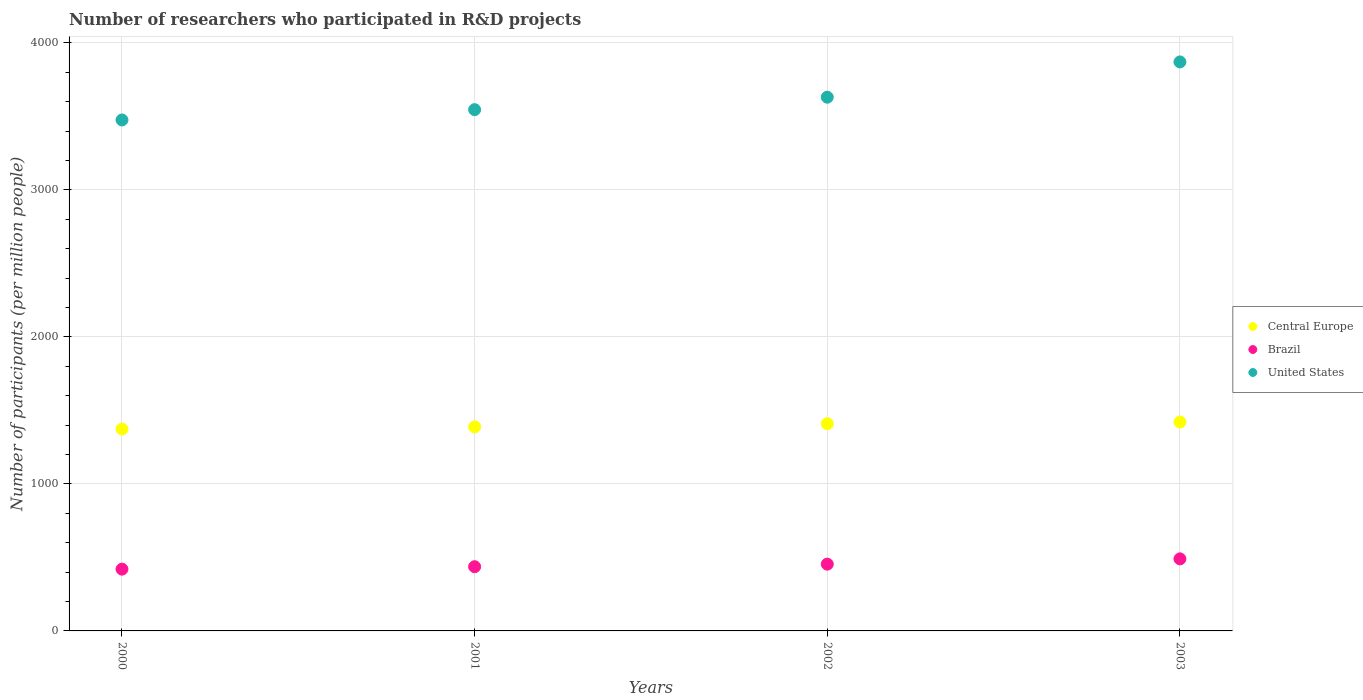What is the number of researchers who participated in R&D projects in Brazil in 2002?
Provide a succinct answer. 454.21. Across all years, what is the maximum number of researchers who participated in R&D projects in Central Europe?
Provide a short and direct response. 1420.86. Across all years, what is the minimum number of researchers who participated in R&D projects in Central Europe?
Offer a terse response. 1373.22. In which year was the number of researchers who participated in R&D projects in United States maximum?
Keep it short and to the point. 2003. In which year was the number of researchers who participated in R&D projects in Brazil minimum?
Your answer should be very brief. 2000. What is the total number of researchers who participated in R&D projects in Brazil in the graph?
Your response must be concise. 1801.45. What is the difference between the number of researchers who participated in R&D projects in United States in 2001 and that in 2002?
Offer a very short reply. -84.77. What is the difference between the number of researchers who participated in R&D projects in United States in 2002 and the number of researchers who participated in R&D projects in Brazil in 2000?
Your answer should be very brief. 3210.07. What is the average number of researchers who participated in R&D projects in Central Europe per year?
Offer a very short reply. 1397.9. In the year 2001, what is the difference between the number of researchers who participated in R&D projects in Brazil and number of researchers who participated in R&D projects in United States?
Make the answer very short. -3108.79. What is the ratio of the number of researchers who participated in R&D projects in United States in 2001 to that in 2003?
Offer a terse response. 0.92. Is the difference between the number of researchers who participated in R&D projects in Brazil in 2000 and 2001 greater than the difference between the number of researchers who participated in R&D projects in United States in 2000 and 2001?
Provide a short and direct response. Yes. What is the difference between the highest and the second highest number of researchers who participated in R&D projects in Brazil?
Your response must be concise. 36.01. What is the difference between the highest and the lowest number of researchers who participated in R&D projects in United States?
Provide a succinct answer. 394.69. In how many years, is the number of researchers who participated in R&D projects in Central Europe greater than the average number of researchers who participated in R&D projects in Central Europe taken over all years?
Provide a succinct answer. 2. Does the number of researchers who participated in R&D projects in United States monotonically increase over the years?
Offer a terse response. Yes. Is the number of researchers who participated in R&D projects in Central Europe strictly greater than the number of researchers who participated in R&D projects in United States over the years?
Ensure brevity in your answer.  No. Are the values on the major ticks of Y-axis written in scientific E-notation?
Offer a terse response. No. Where does the legend appear in the graph?
Give a very brief answer. Center right. How many legend labels are there?
Provide a succinct answer. 3. What is the title of the graph?
Keep it short and to the point. Number of researchers who participated in R&D projects. What is the label or title of the X-axis?
Keep it short and to the point. Years. What is the label or title of the Y-axis?
Your answer should be very brief. Number of participants (per million people). What is the Number of participants (per million people) of Central Europe in 2000?
Make the answer very short. 1373.22. What is the Number of participants (per million people) in Brazil in 2000?
Your answer should be compact. 420.25. What is the Number of participants (per million people) of United States in 2000?
Keep it short and to the point. 3475.52. What is the Number of participants (per million people) of Central Europe in 2001?
Offer a very short reply. 1388.07. What is the Number of participants (per million people) of Brazil in 2001?
Your response must be concise. 436.76. What is the Number of participants (per million people) in United States in 2001?
Give a very brief answer. 3545.56. What is the Number of participants (per million people) of Central Europe in 2002?
Offer a terse response. 1409.43. What is the Number of participants (per million people) of Brazil in 2002?
Provide a succinct answer. 454.21. What is the Number of participants (per million people) in United States in 2002?
Provide a short and direct response. 3630.32. What is the Number of participants (per million people) in Central Europe in 2003?
Offer a terse response. 1420.86. What is the Number of participants (per million people) in Brazil in 2003?
Your answer should be very brief. 490.22. What is the Number of participants (per million people) of United States in 2003?
Make the answer very short. 3870.21. Across all years, what is the maximum Number of participants (per million people) of Central Europe?
Your answer should be very brief. 1420.86. Across all years, what is the maximum Number of participants (per million people) in Brazil?
Offer a terse response. 490.22. Across all years, what is the maximum Number of participants (per million people) in United States?
Provide a succinct answer. 3870.21. Across all years, what is the minimum Number of participants (per million people) of Central Europe?
Keep it short and to the point. 1373.22. Across all years, what is the minimum Number of participants (per million people) of Brazil?
Offer a terse response. 420.25. Across all years, what is the minimum Number of participants (per million people) in United States?
Your answer should be very brief. 3475.52. What is the total Number of participants (per million people) in Central Europe in the graph?
Your answer should be compact. 5591.58. What is the total Number of participants (per million people) in Brazil in the graph?
Your response must be concise. 1801.45. What is the total Number of participants (per million people) in United States in the graph?
Offer a terse response. 1.45e+04. What is the difference between the Number of participants (per million people) in Central Europe in 2000 and that in 2001?
Provide a succinct answer. -14.85. What is the difference between the Number of participants (per million people) in Brazil in 2000 and that in 2001?
Your answer should be very brief. -16.51. What is the difference between the Number of participants (per million people) in United States in 2000 and that in 2001?
Your response must be concise. -70.04. What is the difference between the Number of participants (per million people) in Central Europe in 2000 and that in 2002?
Provide a succinct answer. -36.21. What is the difference between the Number of participants (per million people) of Brazil in 2000 and that in 2002?
Keep it short and to the point. -33.96. What is the difference between the Number of participants (per million people) of United States in 2000 and that in 2002?
Your answer should be very brief. -154.81. What is the difference between the Number of participants (per million people) in Central Europe in 2000 and that in 2003?
Make the answer very short. -47.63. What is the difference between the Number of participants (per million people) of Brazil in 2000 and that in 2003?
Your answer should be compact. -69.97. What is the difference between the Number of participants (per million people) in United States in 2000 and that in 2003?
Your answer should be compact. -394.69. What is the difference between the Number of participants (per million people) of Central Europe in 2001 and that in 2002?
Provide a succinct answer. -21.37. What is the difference between the Number of participants (per million people) in Brazil in 2001 and that in 2002?
Offer a terse response. -17.45. What is the difference between the Number of participants (per million people) in United States in 2001 and that in 2002?
Offer a terse response. -84.77. What is the difference between the Number of participants (per million people) in Central Europe in 2001 and that in 2003?
Provide a succinct answer. -32.79. What is the difference between the Number of participants (per million people) of Brazil in 2001 and that in 2003?
Your answer should be compact. -53.46. What is the difference between the Number of participants (per million people) of United States in 2001 and that in 2003?
Your answer should be compact. -324.65. What is the difference between the Number of participants (per million people) in Central Europe in 2002 and that in 2003?
Make the answer very short. -11.42. What is the difference between the Number of participants (per million people) in Brazil in 2002 and that in 2003?
Give a very brief answer. -36.01. What is the difference between the Number of participants (per million people) of United States in 2002 and that in 2003?
Your answer should be compact. -239.88. What is the difference between the Number of participants (per million people) of Central Europe in 2000 and the Number of participants (per million people) of Brazil in 2001?
Your response must be concise. 936.46. What is the difference between the Number of participants (per million people) of Central Europe in 2000 and the Number of participants (per million people) of United States in 2001?
Offer a terse response. -2172.33. What is the difference between the Number of participants (per million people) of Brazil in 2000 and the Number of participants (per million people) of United States in 2001?
Provide a succinct answer. -3125.3. What is the difference between the Number of participants (per million people) in Central Europe in 2000 and the Number of participants (per million people) in Brazil in 2002?
Provide a succinct answer. 919.01. What is the difference between the Number of participants (per million people) of Central Europe in 2000 and the Number of participants (per million people) of United States in 2002?
Give a very brief answer. -2257.1. What is the difference between the Number of participants (per million people) in Brazil in 2000 and the Number of participants (per million people) in United States in 2002?
Your answer should be very brief. -3210.07. What is the difference between the Number of participants (per million people) in Central Europe in 2000 and the Number of participants (per million people) in Brazil in 2003?
Keep it short and to the point. 883. What is the difference between the Number of participants (per million people) in Central Europe in 2000 and the Number of participants (per million people) in United States in 2003?
Provide a succinct answer. -2496.98. What is the difference between the Number of participants (per million people) in Brazil in 2000 and the Number of participants (per million people) in United States in 2003?
Provide a short and direct response. -3449.95. What is the difference between the Number of participants (per million people) of Central Europe in 2001 and the Number of participants (per million people) of Brazil in 2002?
Offer a very short reply. 933.86. What is the difference between the Number of participants (per million people) of Central Europe in 2001 and the Number of participants (per million people) of United States in 2002?
Provide a succinct answer. -2242.25. What is the difference between the Number of participants (per million people) of Brazil in 2001 and the Number of participants (per million people) of United States in 2002?
Your response must be concise. -3193.56. What is the difference between the Number of participants (per million people) in Central Europe in 2001 and the Number of participants (per million people) in Brazil in 2003?
Make the answer very short. 897.85. What is the difference between the Number of participants (per million people) in Central Europe in 2001 and the Number of participants (per million people) in United States in 2003?
Provide a short and direct response. -2482.14. What is the difference between the Number of participants (per million people) of Brazil in 2001 and the Number of participants (per million people) of United States in 2003?
Offer a terse response. -3433.44. What is the difference between the Number of participants (per million people) in Central Europe in 2002 and the Number of participants (per million people) in Brazil in 2003?
Give a very brief answer. 919.21. What is the difference between the Number of participants (per million people) in Central Europe in 2002 and the Number of participants (per million people) in United States in 2003?
Make the answer very short. -2460.77. What is the difference between the Number of participants (per million people) of Brazil in 2002 and the Number of participants (per million people) of United States in 2003?
Make the answer very short. -3415.99. What is the average Number of participants (per million people) in Central Europe per year?
Keep it short and to the point. 1397.9. What is the average Number of participants (per million people) of Brazil per year?
Provide a short and direct response. 450.36. What is the average Number of participants (per million people) in United States per year?
Provide a short and direct response. 3630.4. In the year 2000, what is the difference between the Number of participants (per million people) of Central Europe and Number of participants (per million people) of Brazil?
Provide a short and direct response. 952.97. In the year 2000, what is the difference between the Number of participants (per million people) of Central Europe and Number of participants (per million people) of United States?
Keep it short and to the point. -2102.29. In the year 2000, what is the difference between the Number of participants (per million people) in Brazil and Number of participants (per million people) in United States?
Offer a terse response. -3055.26. In the year 2001, what is the difference between the Number of participants (per million people) in Central Europe and Number of participants (per million people) in Brazil?
Provide a succinct answer. 951.3. In the year 2001, what is the difference between the Number of participants (per million people) in Central Europe and Number of participants (per million people) in United States?
Your answer should be very brief. -2157.49. In the year 2001, what is the difference between the Number of participants (per million people) in Brazil and Number of participants (per million people) in United States?
Make the answer very short. -3108.79. In the year 2002, what is the difference between the Number of participants (per million people) in Central Europe and Number of participants (per million people) in Brazil?
Offer a very short reply. 955.22. In the year 2002, what is the difference between the Number of participants (per million people) in Central Europe and Number of participants (per million people) in United States?
Give a very brief answer. -2220.89. In the year 2002, what is the difference between the Number of participants (per million people) in Brazil and Number of participants (per million people) in United States?
Offer a terse response. -3176.11. In the year 2003, what is the difference between the Number of participants (per million people) in Central Europe and Number of participants (per million people) in Brazil?
Ensure brevity in your answer.  930.63. In the year 2003, what is the difference between the Number of participants (per million people) of Central Europe and Number of participants (per million people) of United States?
Your response must be concise. -2449.35. In the year 2003, what is the difference between the Number of participants (per million people) of Brazil and Number of participants (per million people) of United States?
Provide a succinct answer. -3379.99. What is the ratio of the Number of participants (per million people) in Central Europe in 2000 to that in 2001?
Offer a terse response. 0.99. What is the ratio of the Number of participants (per million people) of Brazil in 2000 to that in 2001?
Provide a short and direct response. 0.96. What is the ratio of the Number of participants (per million people) in United States in 2000 to that in 2001?
Your answer should be very brief. 0.98. What is the ratio of the Number of participants (per million people) in Central Europe in 2000 to that in 2002?
Make the answer very short. 0.97. What is the ratio of the Number of participants (per million people) of Brazil in 2000 to that in 2002?
Provide a succinct answer. 0.93. What is the ratio of the Number of participants (per million people) of United States in 2000 to that in 2002?
Provide a succinct answer. 0.96. What is the ratio of the Number of participants (per million people) in Central Europe in 2000 to that in 2003?
Your response must be concise. 0.97. What is the ratio of the Number of participants (per million people) of Brazil in 2000 to that in 2003?
Keep it short and to the point. 0.86. What is the ratio of the Number of participants (per million people) in United States in 2000 to that in 2003?
Provide a succinct answer. 0.9. What is the ratio of the Number of participants (per million people) of Brazil in 2001 to that in 2002?
Provide a short and direct response. 0.96. What is the ratio of the Number of participants (per million people) of United States in 2001 to that in 2002?
Your answer should be very brief. 0.98. What is the ratio of the Number of participants (per million people) in Central Europe in 2001 to that in 2003?
Provide a succinct answer. 0.98. What is the ratio of the Number of participants (per million people) of Brazil in 2001 to that in 2003?
Give a very brief answer. 0.89. What is the ratio of the Number of participants (per million people) of United States in 2001 to that in 2003?
Your answer should be compact. 0.92. What is the ratio of the Number of participants (per million people) of Central Europe in 2002 to that in 2003?
Your answer should be very brief. 0.99. What is the ratio of the Number of participants (per million people) of Brazil in 2002 to that in 2003?
Offer a very short reply. 0.93. What is the ratio of the Number of participants (per million people) of United States in 2002 to that in 2003?
Ensure brevity in your answer.  0.94. What is the difference between the highest and the second highest Number of participants (per million people) in Central Europe?
Provide a short and direct response. 11.42. What is the difference between the highest and the second highest Number of participants (per million people) of Brazil?
Your answer should be very brief. 36.01. What is the difference between the highest and the second highest Number of participants (per million people) of United States?
Offer a very short reply. 239.88. What is the difference between the highest and the lowest Number of participants (per million people) in Central Europe?
Offer a very short reply. 47.63. What is the difference between the highest and the lowest Number of participants (per million people) of Brazil?
Your answer should be compact. 69.97. What is the difference between the highest and the lowest Number of participants (per million people) in United States?
Offer a terse response. 394.69. 